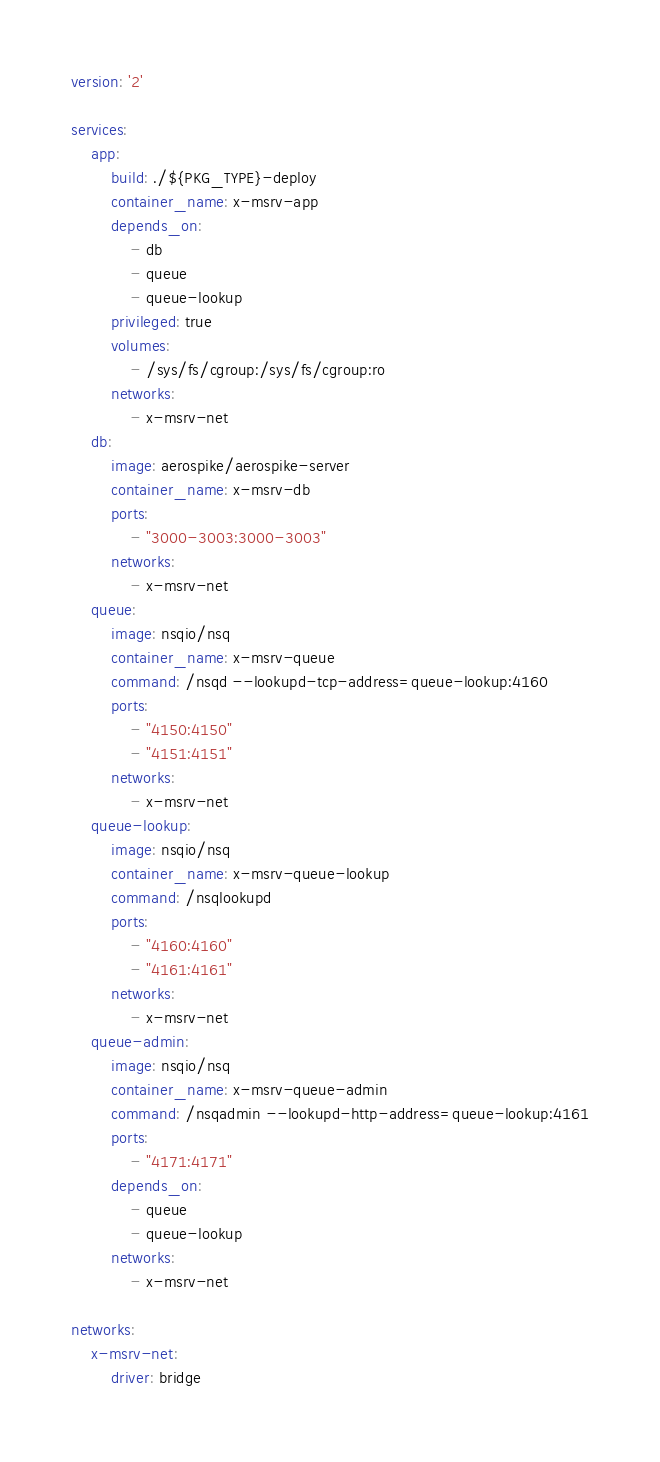Convert code to text. <code><loc_0><loc_0><loc_500><loc_500><_YAML_>version: '2'

services:
    app:
        build: ./${PKG_TYPE}-deploy
        container_name: x-msrv-app
        depends_on:
            - db
            - queue
            - queue-lookup
        privileged: true
        volumes:
            - /sys/fs/cgroup:/sys/fs/cgroup:ro
        networks:
            - x-msrv-net
    db:
        image: aerospike/aerospike-server
        container_name: x-msrv-db
        ports:
            - "3000-3003:3000-3003"
        networks:
            - x-msrv-net
    queue:
        image: nsqio/nsq
        container_name: x-msrv-queue
        command: /nsqd --lookupd-tcp-address=queue-lookup:4160
        ports:
            - "4150:4150"
            - "4151:4151"
        networks:
            - x-msrv-net
    queue-lookup:
        image: nsqio/nsq
        container_name: x-msrv-queue-lookup
        command: /nsqlookupd
        ports:
            - "4160:4160"
            - "4161:4161"
        networks:
            - x-msrv-net
    queue-admin:
        image: nsqio/nsq
        container_name: x-msrv-queue-admin
        command: /nsqadmin --lookupd-http-address=queue-lookup:4161
        ports:
            - "4171:4171"
        depends_on:
            - queue
            - queue-lookup
        networks:
            - x-msrv-net

networks:
    x-msrv-net:
        driver: bridge
</code> 